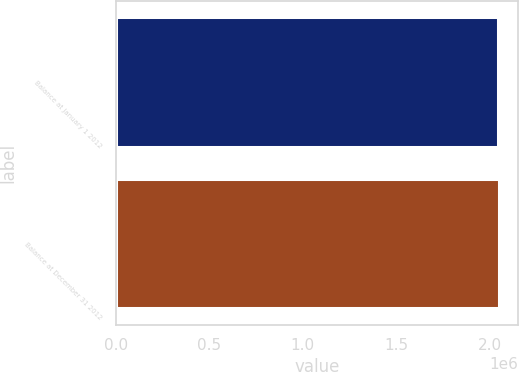Convert chart. <chart><loc_0><loc_0><loc_500><loc_500><bar_chart><fcel>Balance at January 1 2012<fcel>Balance at December 31 2012<nl><fcel>2.04752e+06<fcel>2.04931e+06<nl></chart> 